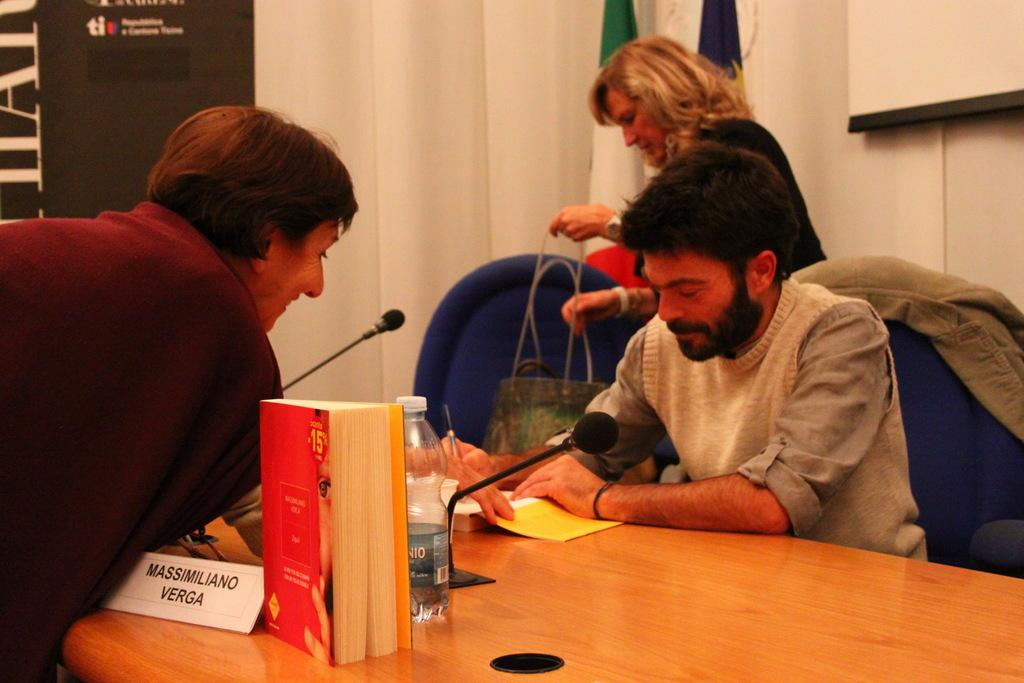Provide a one-sentence caption for the provided image. A man leans over a desk towards him as Massimiliano Verga signs his book. 